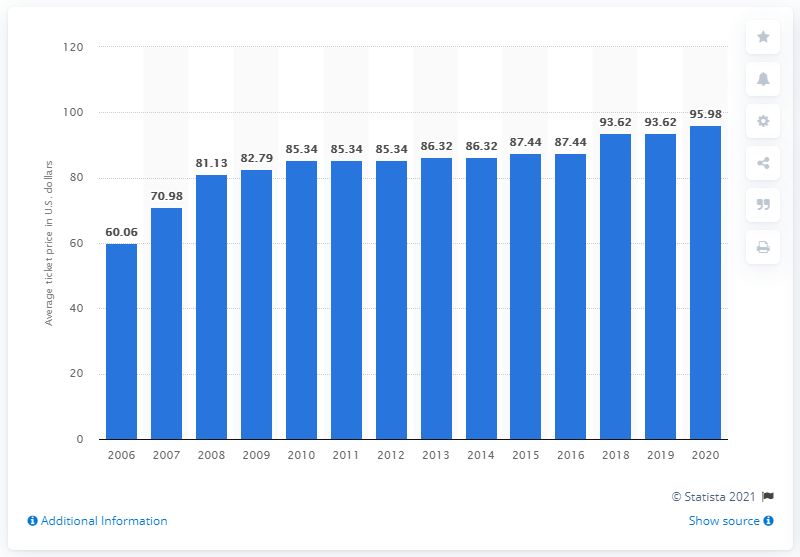List a handful of essential elements in this visual. In 2020, the average ticket price for Indianapolis Colts games was 95.98 USD. 